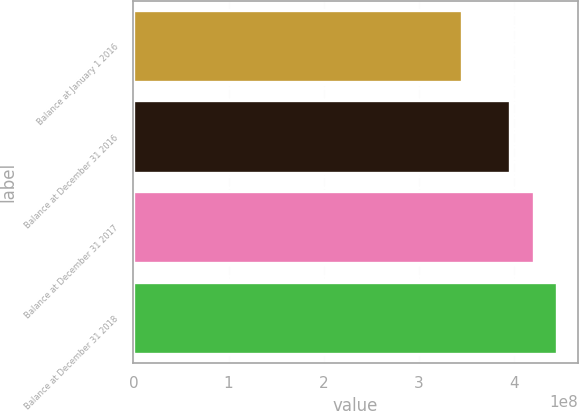Convert chart. <chart><loc_0><loc_0><loc_500><loc_500><bar_chart><fcel>Balance at January 1 2016<fcel>Balance at December 31 2016<fcel>Balance at December 31 2017<fcel>Balance at December 31 2018<nl><fcel>3.45637e+08<fcel>3.9511e+08<fcel>4.21222e+08<fcel>4.4462e+08<nl></chart> 